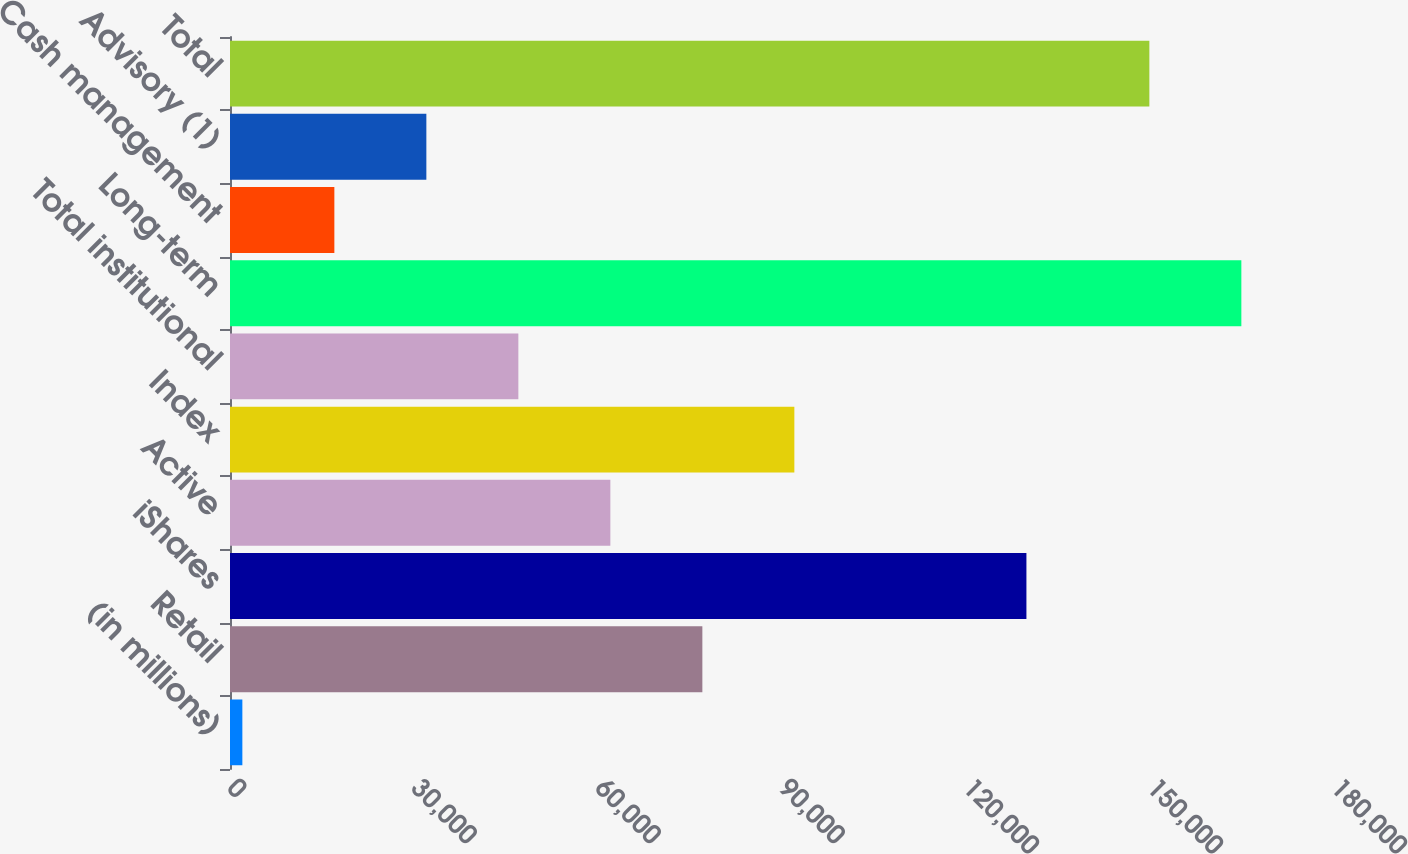<chart> <loc_0><loc_0><loc_500><loc_500><bar_chart><fcel>(in millions)<fcel>Retail<fcel>iShares<fcel>Active<fcel>Index<fcel>Total institutional<fcel>Long-term<fcel>Cash management<fcel>Advisory (1)<fcel>Total<nl><fcel>2015<fcel>77014.5<fcel>129852<fcel>62014.6<fcel>92014.4<fcel>47014.7<fcel>164895<fcel>17014.9<fcel>32014.8<fcel>149895<nl></chart> 